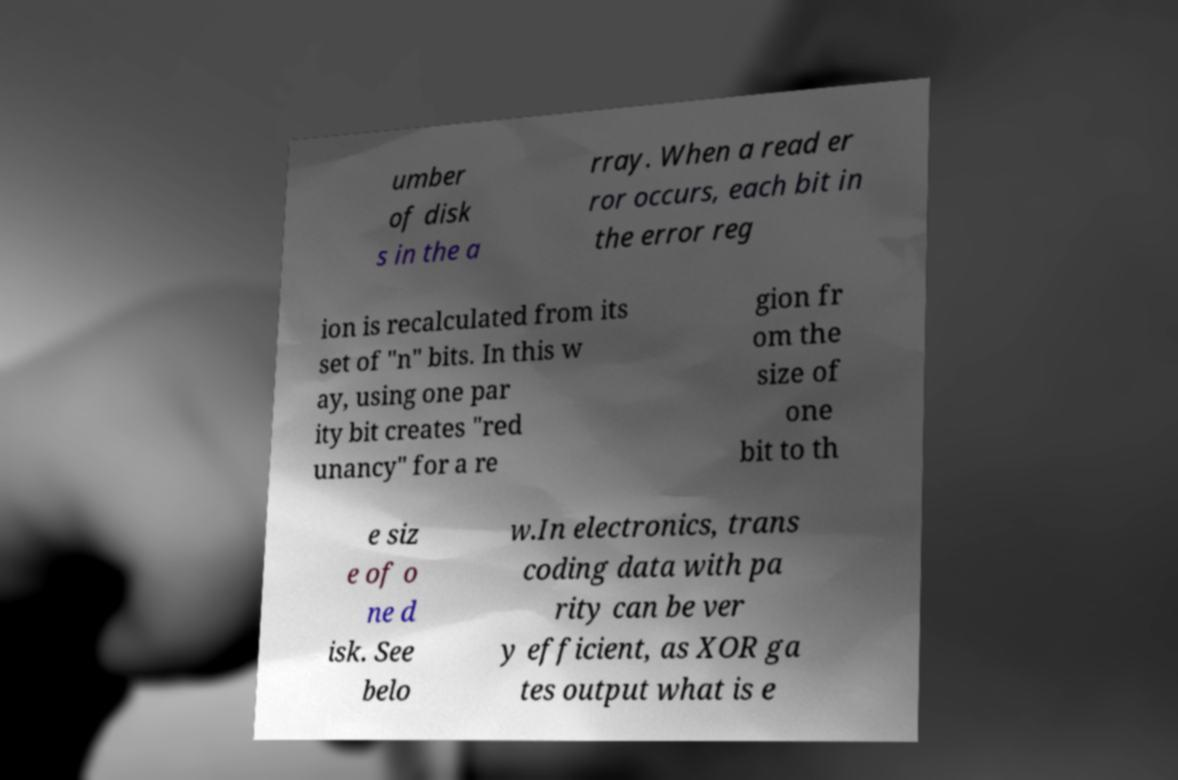Can you accurately transcribe the text from the provided image for me? umber of disk s in the a rray. When a read er ror occurs, each bit in the error reg ion is recalculated from its set of "n" bits. In this w ay, using one par ity bit creates "red unancy" for a re gion fr om the size of one bit to th e siz e of o ne d isk. See belo w.In electronics, trans coding data with pa rity can be ver y efficient, as XOR ga tes output what is e 